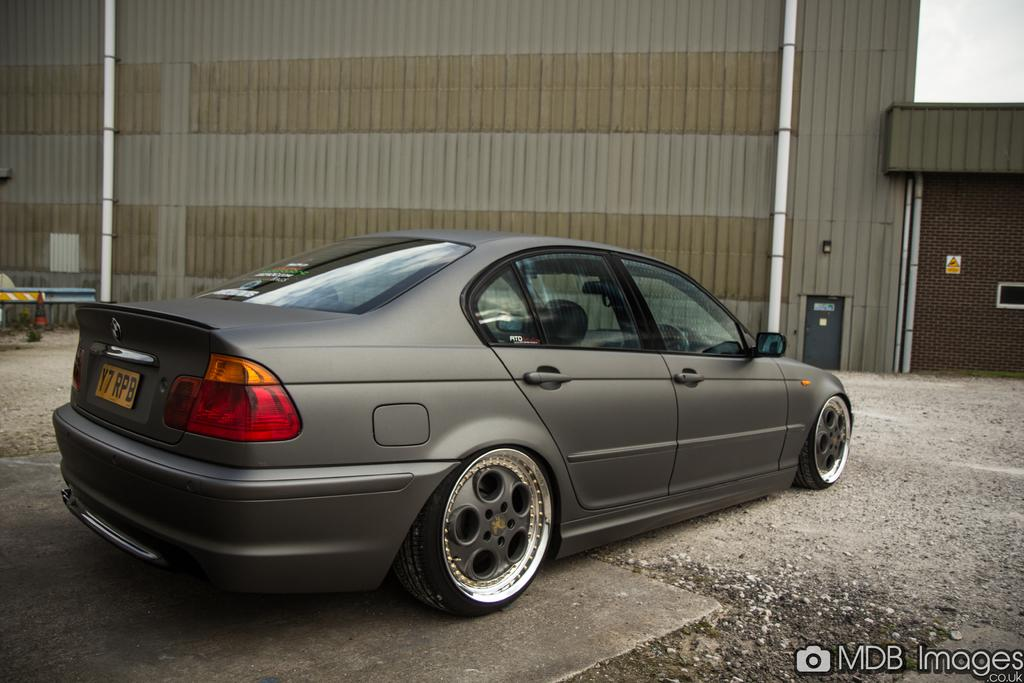What is the main object on the ground in the image? There is a car on the ground in the image. What can be seen in the background of the image? There is a wall and two poles in the background of the image. What part of the natural environment is visible in the image? The sky is visible in the top right corner of the image. What type of company is represented by the logo on the car in the image? There is no logo visible on the car in the image, so it cannot be determined what company it might represent. 